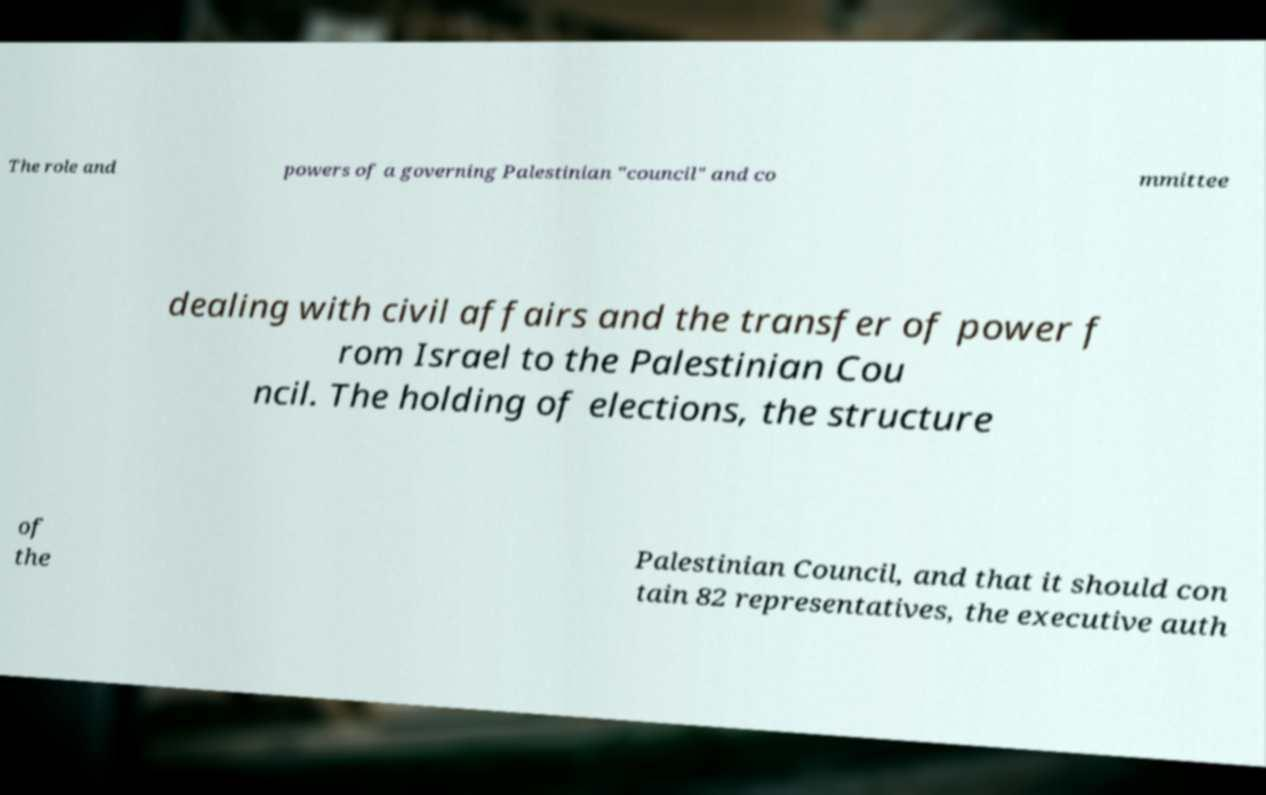For documentation purposes, I need the text within this image transcribed. Could you provide that? The role and powers of a governing Palestinian "council" and co mmittee dealing with civil affairs and the transfer of power f rom Israel to the Palestinian Cou ncil. The holding of elections, the structure of the Palestinian Council, and that it should con tain 82 representatives, the executive auth 